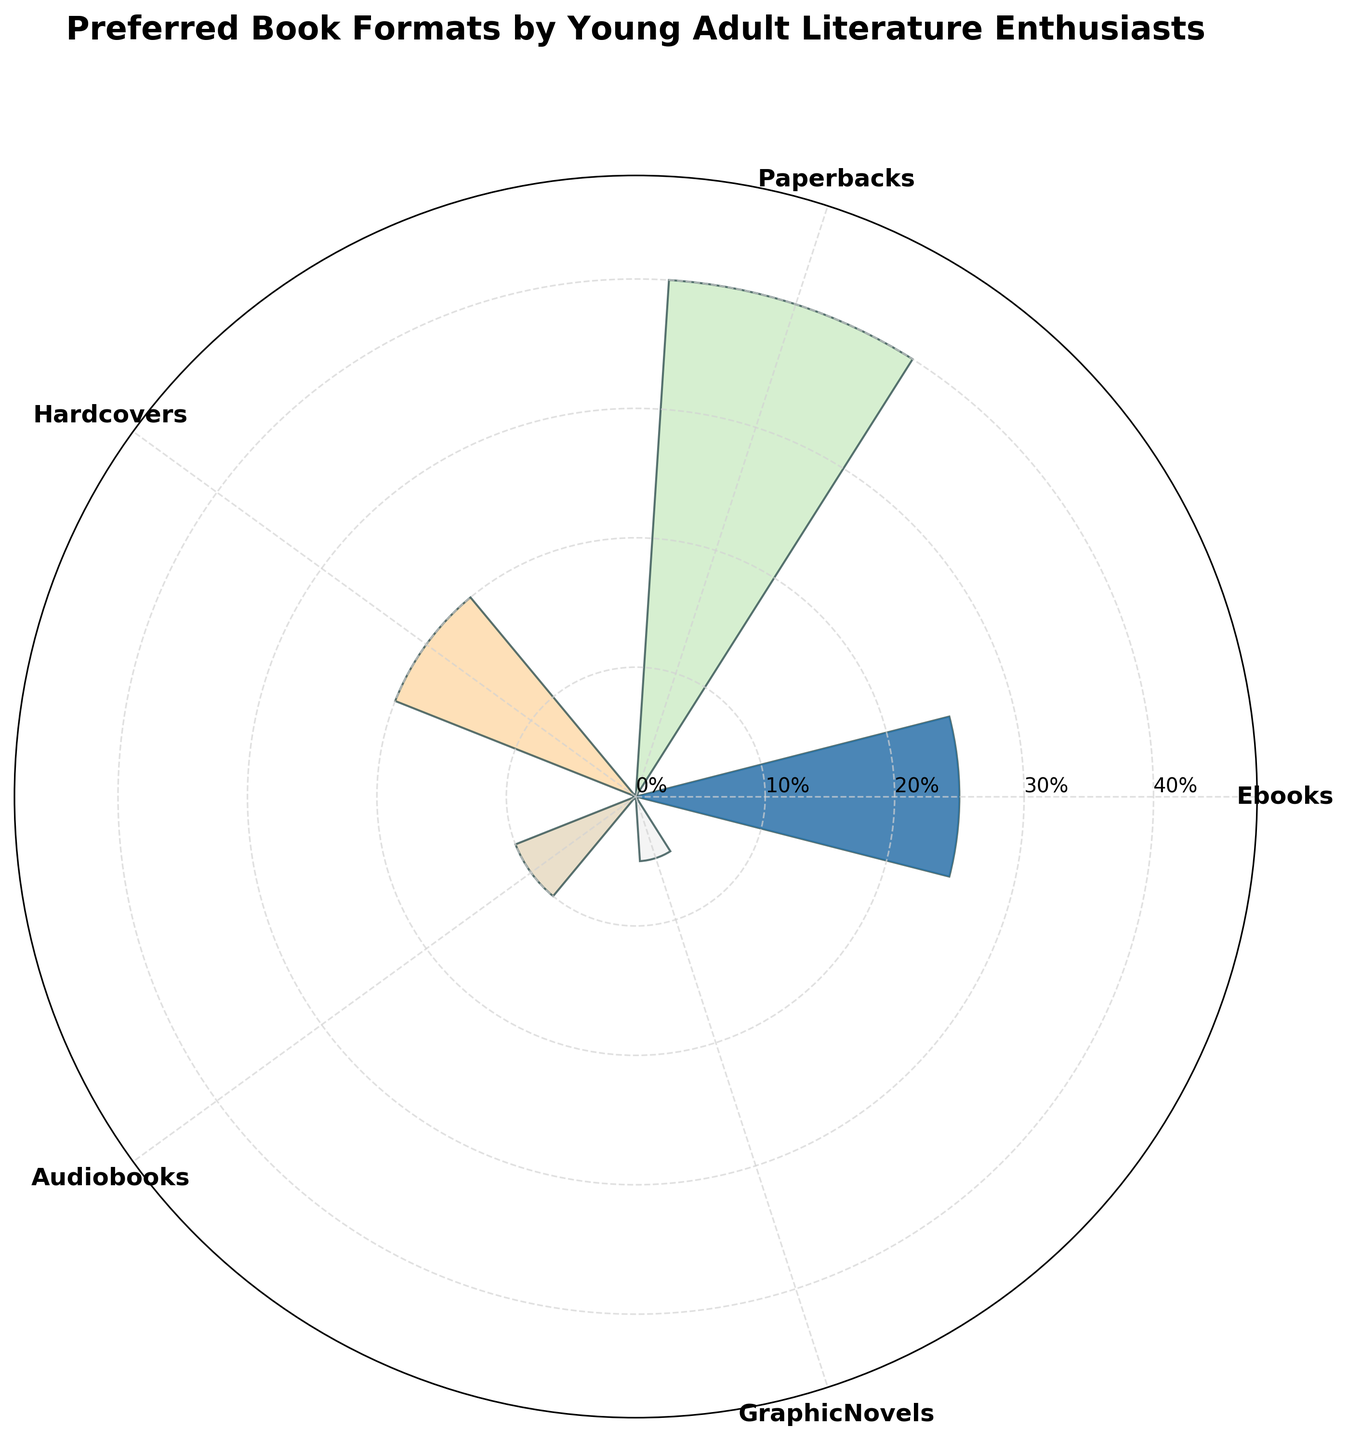What's the title of the chart? The title of the chart is located at the top of the figure and gives an overview of what the chart represents. The title usually appears in bold text.
Answer: "Preferred Book Formats by Young Adult Literature Enthusiasts" How many different book formats are displayed? To determine the number of different book formats, one only needs to count the distinct categories or segments on the polar chart.
Answer: Five Which book format is preferred the most? To find the most preferred book format, look for the segment with the highest percentage value, which is also the largest bar on the polar chart.
Answer: Paperbacks What is the percentage of Hardcover preference? The percentage of Hardcover preference is indicated directly on the corresponding segment of the polar chart. Look for the label that says "Hardcovers" and check its associated value.
Answer: 20% How do the preferences for Ebooks and Audiobooks compare? To compare the preferences, look at the segments labeled "Ebooks" and "Audiobooks" and compare their corresponding percentage values. Ebooks' segment should be larger if its percentage is higher.
Answer: Ebooks are preferred more What is the combined percentage of Paperbacks and Graphic Novels? To find the combined percentage, add the percentage values for Paperbacks and Graphic Novels. Paperbacks are 40% and Graphic Novels are 5%. So, 40% + 5% = 45%.
Answer: 45% What format has the smallest percentage preference? To identify the least preferred format, find the segment with the smallest value on the polar chart.
Answer: Graphic Novels How much more popular are Paperbacks compared to Hardcovers? Subtract the percentage of Hardcovers from the percentage of Paperbacks. Paperbacks are 40% and Hardcovers are 20%. So, 40% - 20% = 20%.
Answer: 20% What is the average preference percentage for all book formats? To calculate the average, sum all the percentages and then divide by the number of formats. The total percentage (25 + 40 + 20 + 10 + 5) is 100. The number of formats is 5. So, 100 / 5 = 20%.
Answer: 20% What are the theta angles used for Audiobooks and Graphic Novels? Theta angles correspond to the angular positions of the segments on the polar chart. They are calculated by dividing the circle into equal parts based on the number of formats. For Audiobooks, since it's the fourth format in the list, its theta is 3 * (2π / 5). For Graphic Novels, it's the fifth format, so its theta is 4 * (2π / 5).
Answer: 3 * (2π / 5) and 4 * (2π / 5) 